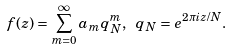<formula> <loc_0><loc_0><loc_500><loc_500>f ( z ) = \sum _ { m = 0 } ^ { \infty } a _ { m } q _ { N } ^ { m } , \ q _ { N } = e ^ { 2 \pi i z / N } .</formula> 